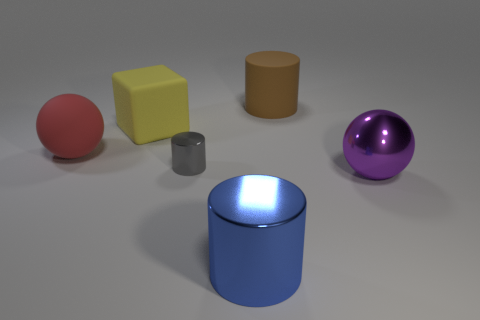There is a cylinder that is behind the purple shiny thing and left of the brown rubber cylinder; what is it made of?
Ensure brevity in your answer.  Metal. There is a big shiny object in front of the big sphere that is in front of the tiny cylinder; what is its shape?
Provide a short and direct response. Cylinder. Are there any other things that have the same color as the tiny shiny thing?
Make the answer very short. No. Is the size of the red sphere the same as the thing behind the big yellow matte object?
Provide a short and direct response. Yes. How many tiny objects are either green cubes or red rubber things?
Keep it short and to the point. 0. Are there more rubber things than large shiny cylinders?
Make the answer very short. Yes. What number of big objects are on the right side of the ball that is on the right side of the big shiny thing in front of the big purple ball?
Make the answer very short. 0. The gray object is what shape?
Provide a succinct answer. Cylinder. What number of other objects are there of the same material as the big cube?
Keep it short and to the point. 2. Do the red thing and the gray cylinder have the same size?
Your answer should be compact. No. 